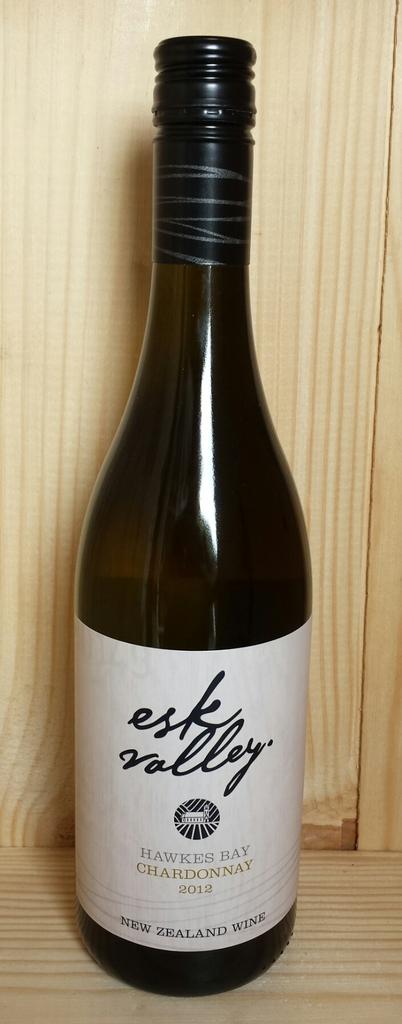What country was this made?
Your response must be concise. New zealand. 